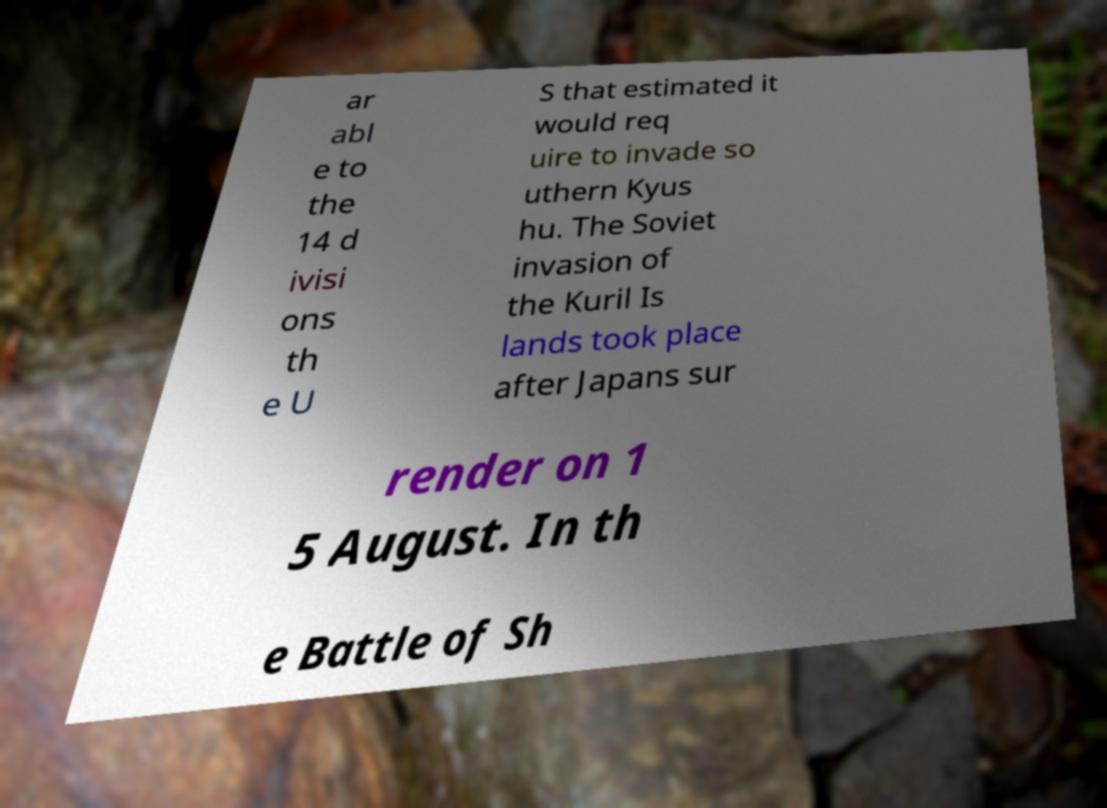Can you accurately transcribe the text from the provided image for me? ar abl e to the 14 d ivisi ons th e U S that estimated it would req uire to invade so uthern Kyus hu. The Soviet invasion of the Kuril Is lands took place after Japans sur render on 1 5 August. In th e Battle of Sh 